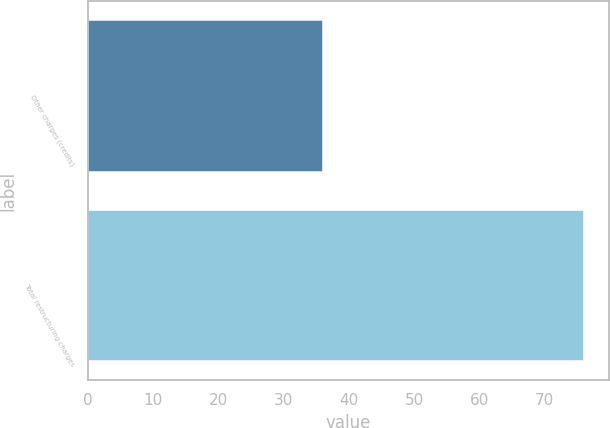Convert chart. <chart><loc_0><loc_0><loc_500><loc_500><bar_chart><fcel>Other charges (credits)<fcel>Total restructuring charges<nl><fcel>36<fcel>76<nl></chart> 